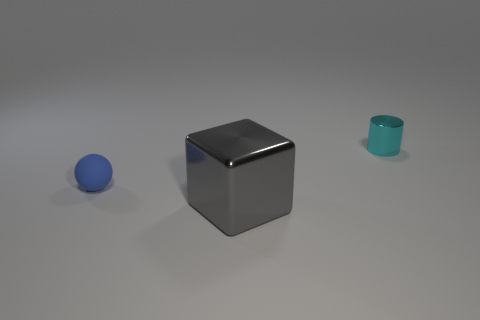Is the number of tiny metal things right of the small blue object less than the number of small matte cylinders?
Offer a terse response. No. What is the material of the object that is on the right side of the big gray shiny cube in front of the rubber object?
Provide a succinct answer. Metal. There is a object that is behind the gray metal block and right of the tiny blue thing; what shape is it?
Your answer should be very brief. Cylinder. What number of things are things to the right of the matte sphere or big cubes?
Make the answer very short. 2. Is there any other thing that has the same size as the gray block?
Make the answer very short. No. How big is the object that is in front of the tiny thing that is left of the tiny cyan shiny thing?
Keep it short and to the point. Large. How many things are small red rubber blocks or tiny blue rubber objects that are in front of the cyan cylinder?
Make the answer very short. 1. There is a tiny thing behind the thing that is on the left side of the shiny cube; what number of small blue rubber spheres are in front of it?
Make the answer very short. 1. How many things are spheres or cyan shiny objects?
Ensure brevity in your answer.  2. Do the gray metal thing and the object that is behind the rubber sphere have the same shape?
Provide a succinct answer. No. 